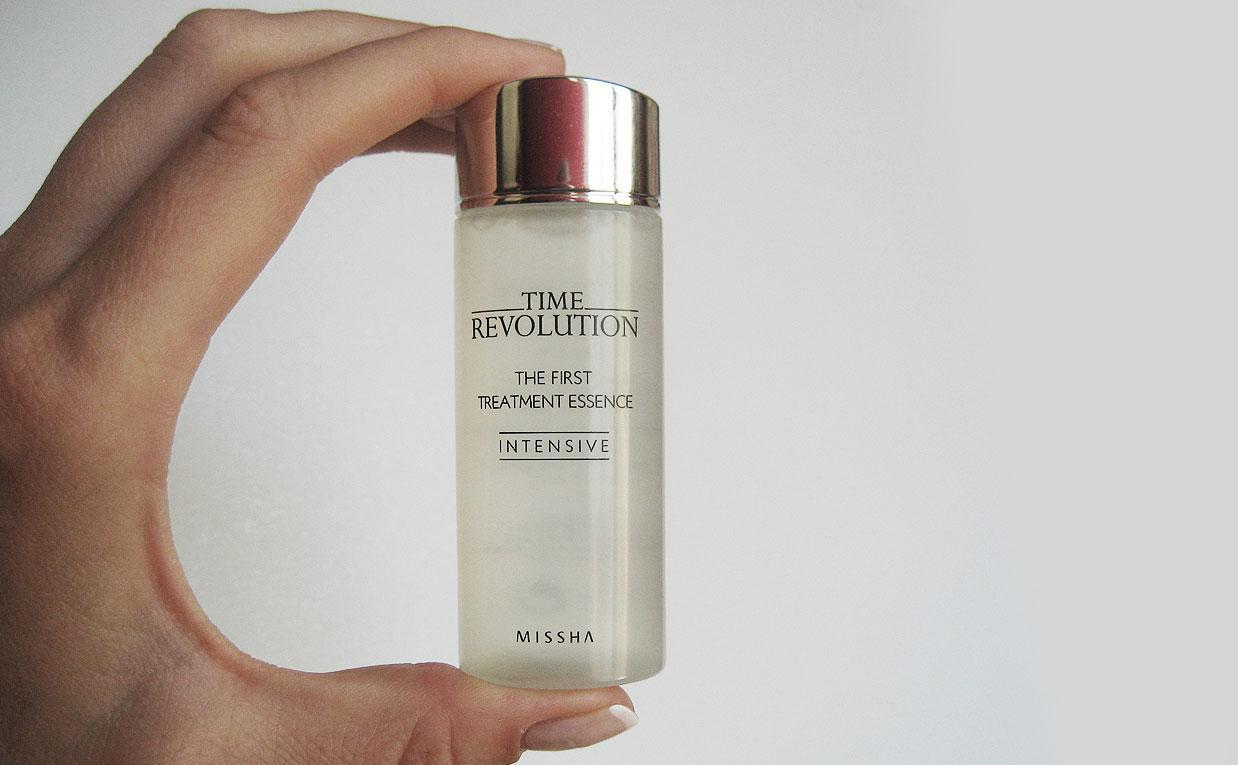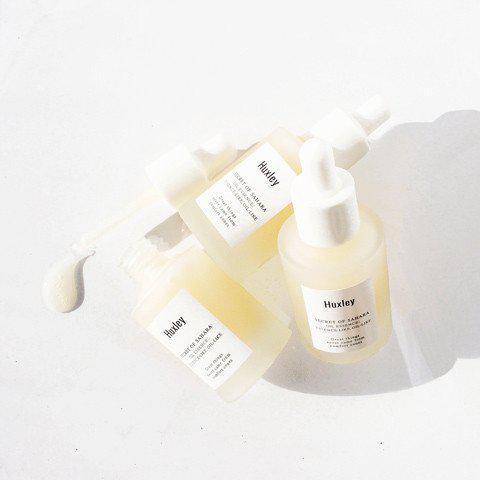The first image is the image on the left, the second image is the image on the right. Evaluate the accuracy of this statement regarding the images: "Four or more skin products are standing upright on a counter in the left photo.". Is it true? Answer yes or no. No. The first image is the image on the left, the second image is the image on the right. Given the left and right images, does the statement "An image shows exactly one skincare product, which has a gold cap." hold true? Answer yes or no. Yes. 